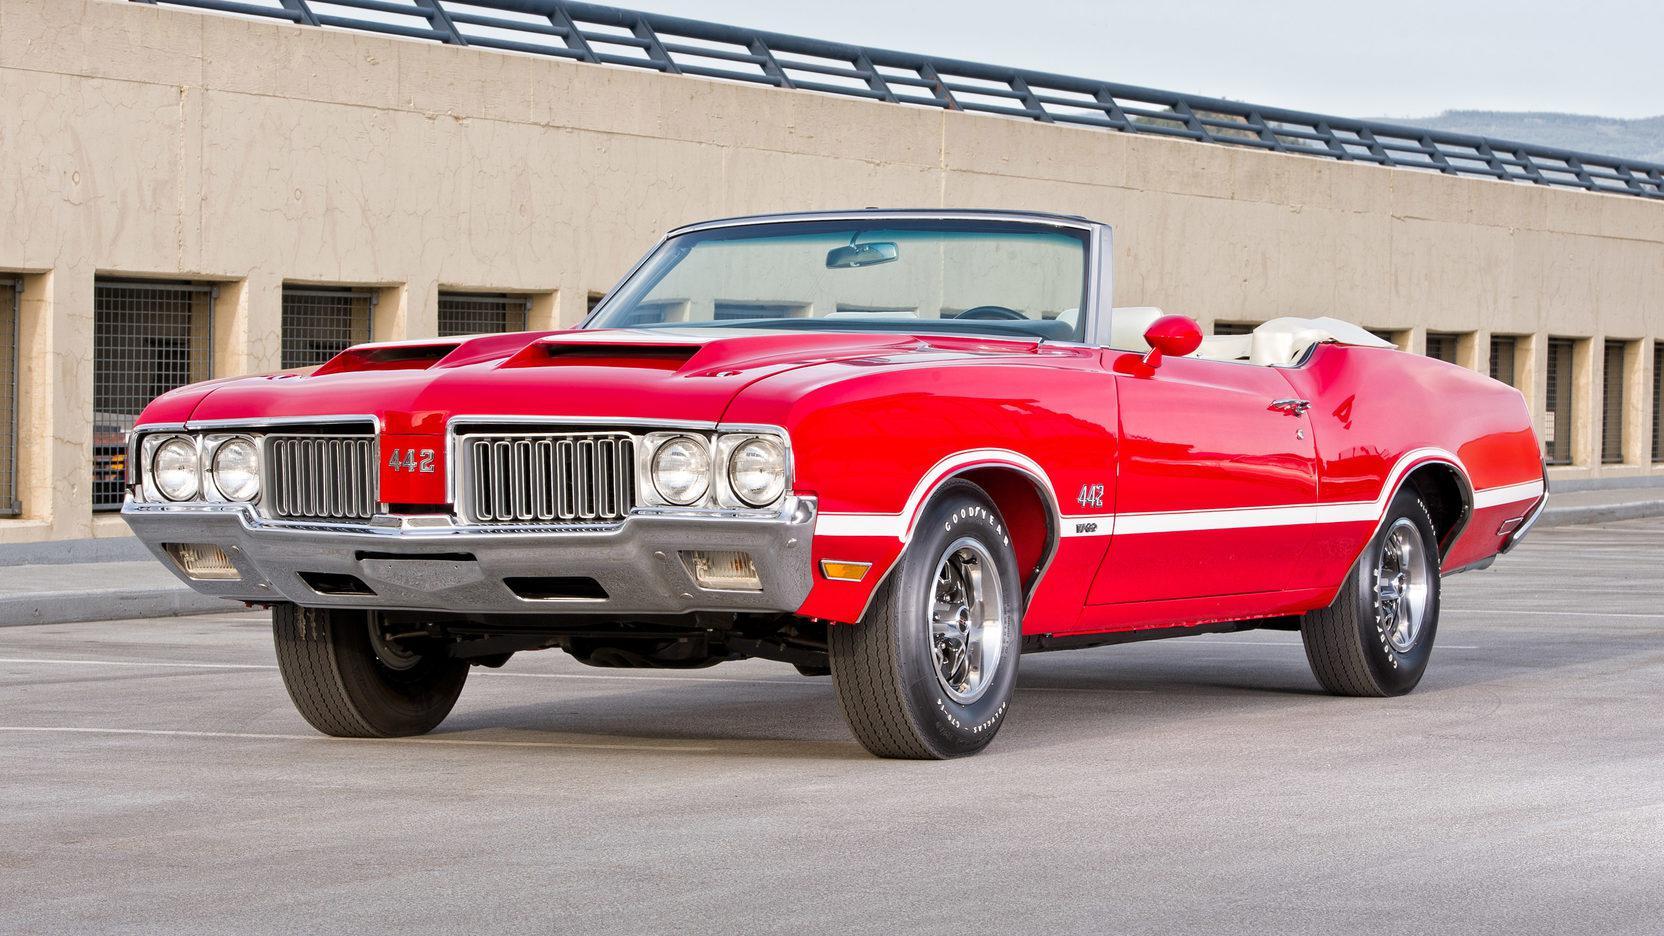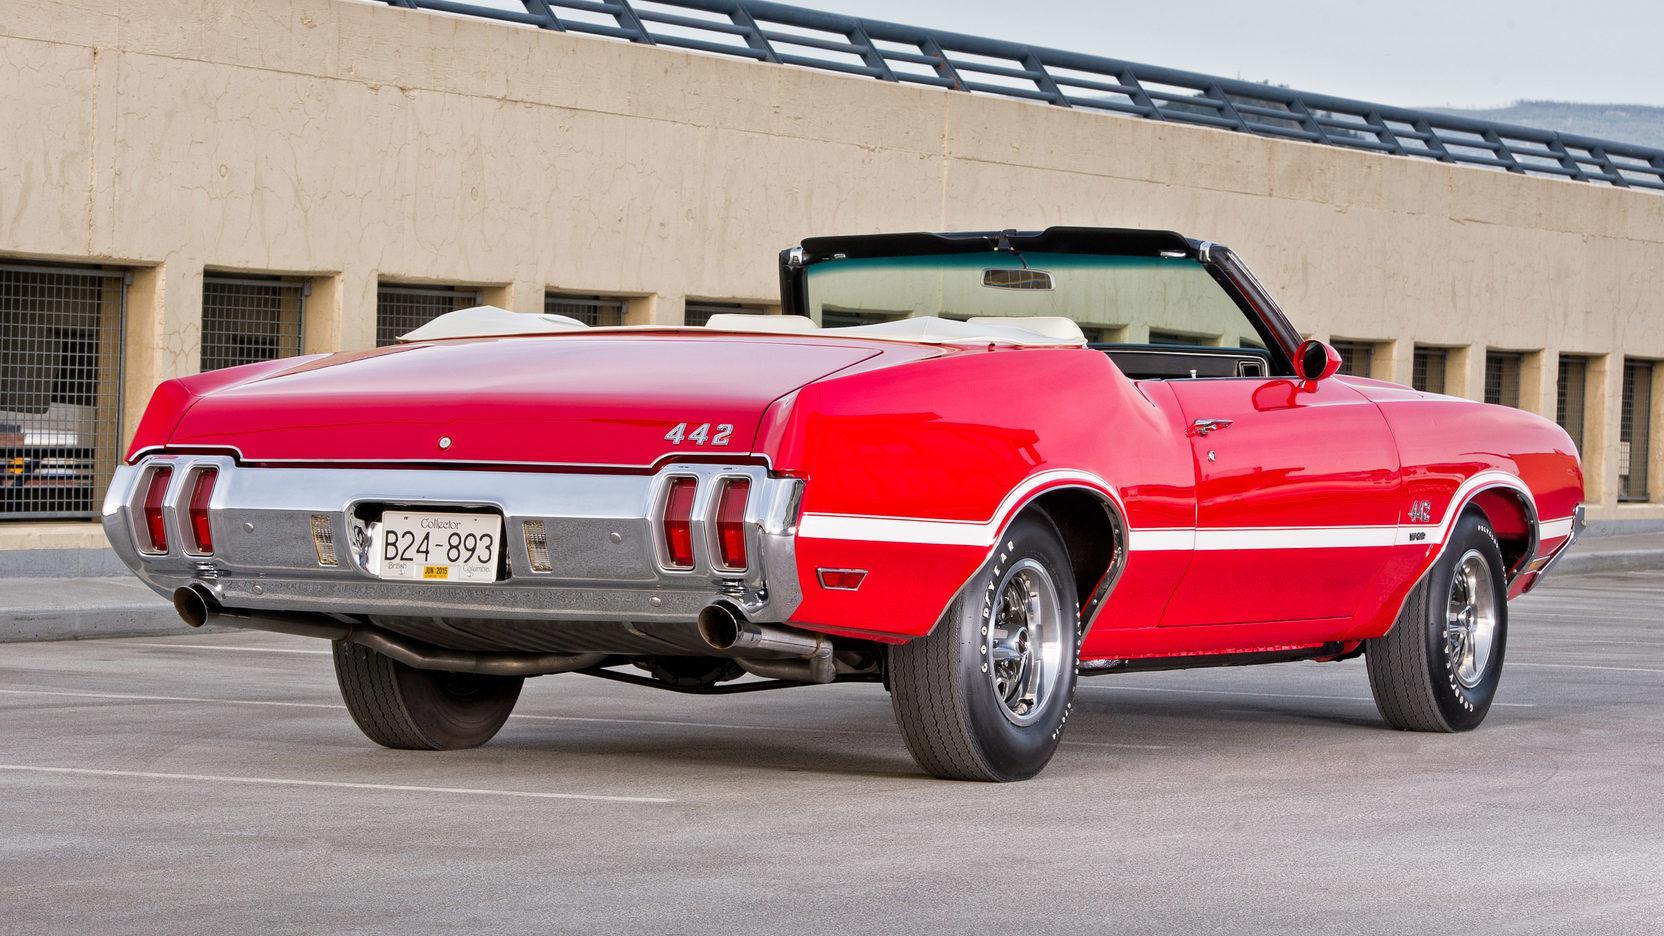The first image is the image on the left, the second image is the image on the right. Given the left and right images, does the statement "In each image, the front grille of the car is visible." hold true? Answer yes or no. No. 